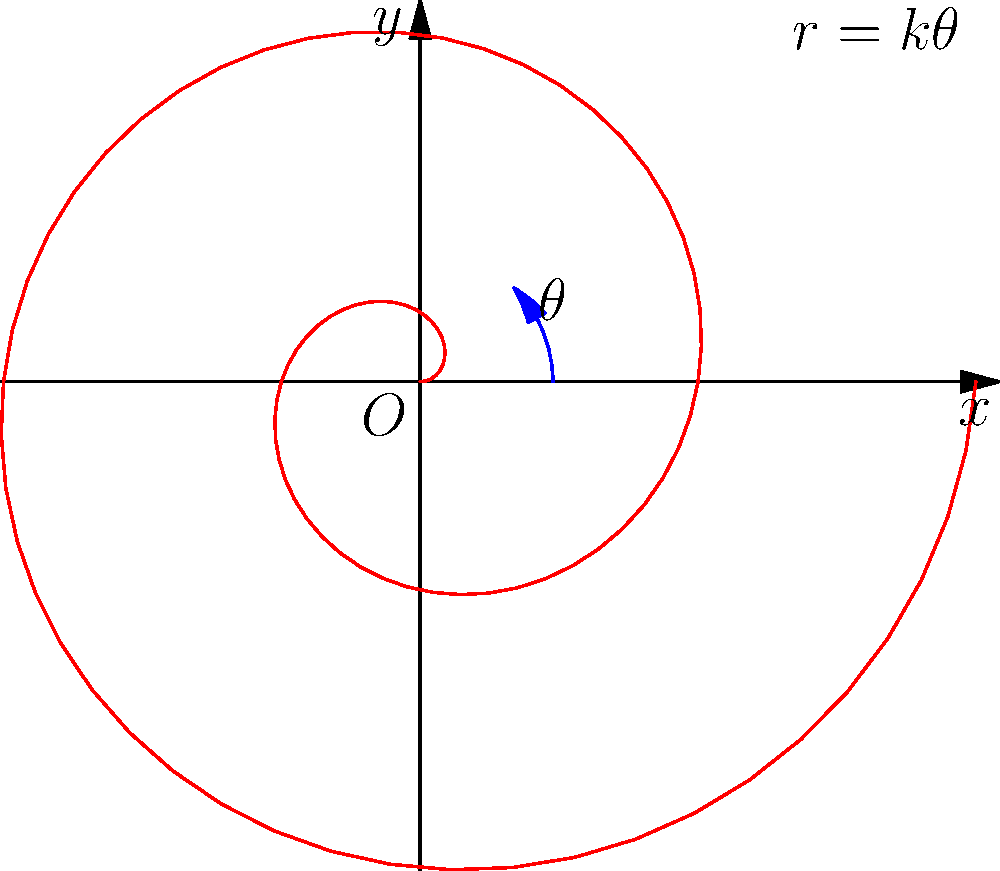In the polar coordinate representation of the Archimedean spiral given by the equation $r = k\theta$, where $k$ is a constant, what crucial element is missing from the labeling of the graph? To answer this question, let's analyze the given graph and its labeling:

1. The graph shows a red spiral curve, which represents the Archimedean spiral $r = k\theta$.
2. The x-axis and y-axis are properly labeled with arrows.
3. The origin is labeled as "O".
4. The equation $r = k\theta$ is provided on the graph.
5. The angle $\theta$ is indicated with a blue arc and labeled.

However, upon careful inspection, we notice that a critical element is missing from the labeling:

6. The radial distance $r$ is not explicitly labeled on the graph.

In polar coordinates, both $r$ (the radial distance from the origin) and $\theta$ (the angle from the positive x-axis) are essential components. While $\theta$ is clearly marked, there is no indication of $r$ on any point of the spiral.

For a complete and precise representation, a radial line segment should be drawn from the origin to a point on the spiral, and this line segment should be labeled as $r$.

This omission is particularly significant for a language and grammar perfectionist, as precise and complete labeling is crucial for accurate communication in mathematical graphics.
Answer: The radial distance $r$ is not labeled. 